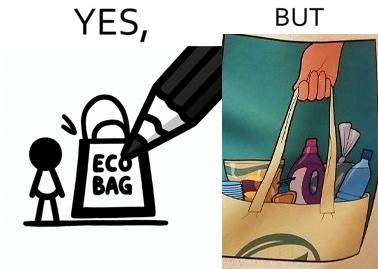What does this image depict? The image is ironical because in the left image it is written eco bag but in the right image we are keeping items of plastic which is not eco-friendly. 